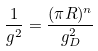<formula> <loc_0><loc_0><loc_500><loc_500>\frac { 1 } { g ^ { 2 } } = \frac { ( \pi R ) ^ { n } } { g _ { D } ^ { 2 } }</formula> 